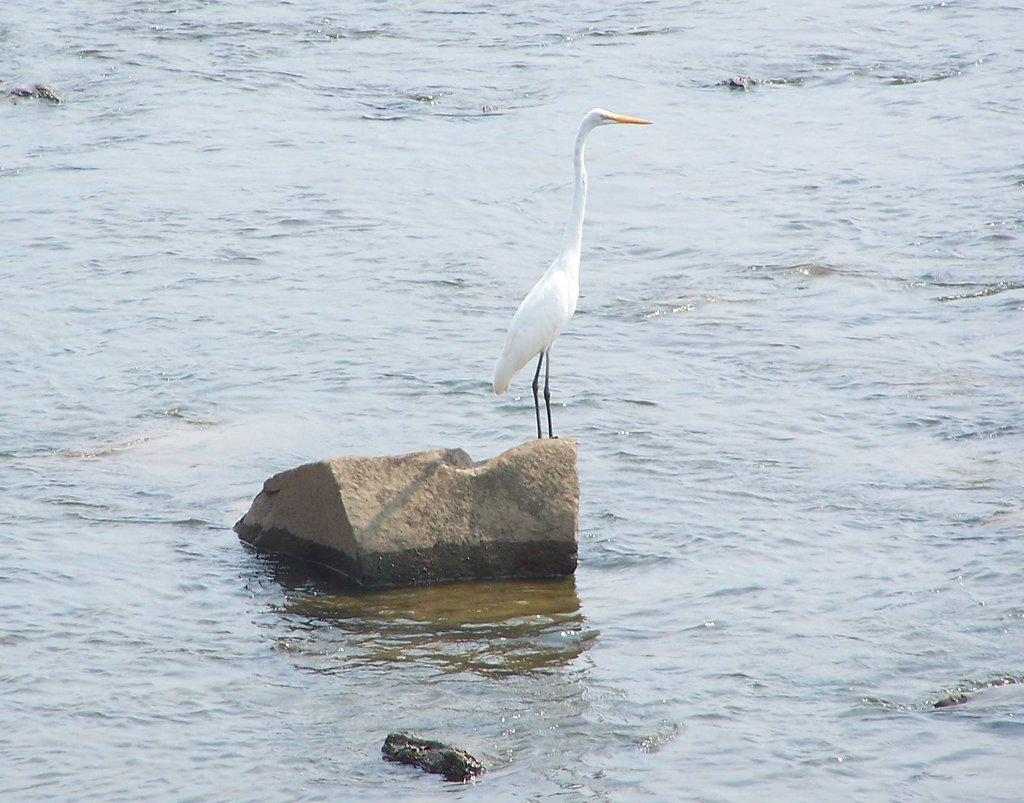What type of natural feature is present in the image? There is a water body in the image. Can you describe the wildlife in the image? There is a crane on a rock in the image. What type of wire is being used to hold the meat in the image? There is no wire or meat present in the image; it features a water body and a crane on a rock. 